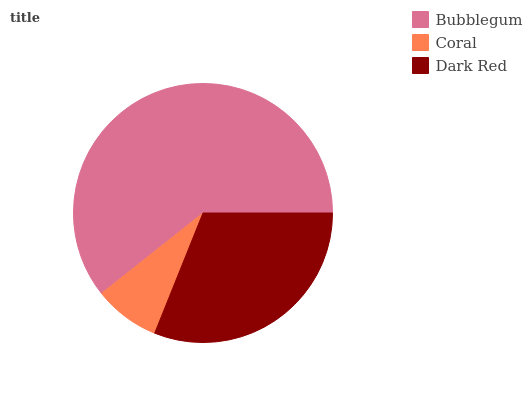Is Coral the minimum?
Answer yes or no. Yes. Is Bubblegum the maximum?
Answer yes or no. Yes. Is Dark Red the minimum?
Answer yes or no. No. Is Dark Red the maximum?
Answer yes or no. No. Is Dark Red greater than Coral?
Answer yes or no. Yes. Is Coral less than Dark Red?
Answer yes or no. Yes. Is Coral greater than Dark Red?
Answer yes or no. No. Is Dark Red less than Coral?
Answer yes or no. No. Is Dark Red the high median?
Answer yes or no. Yes. Is Dark Red the low median?
Answer yes or no. Yes. Is Coral the high median?
Answer yes or no. No. Is Bubblegum the low median?
Answer yes or no. No. 